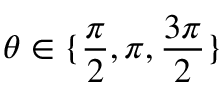Convert formula to latex. <formula><loc_0><loc_0><loc_500><loc_500>\theta \in \{ \frac { \pi } { 2 } , \pi , \frac { 3 \pi } { 2 } \}</formula> 